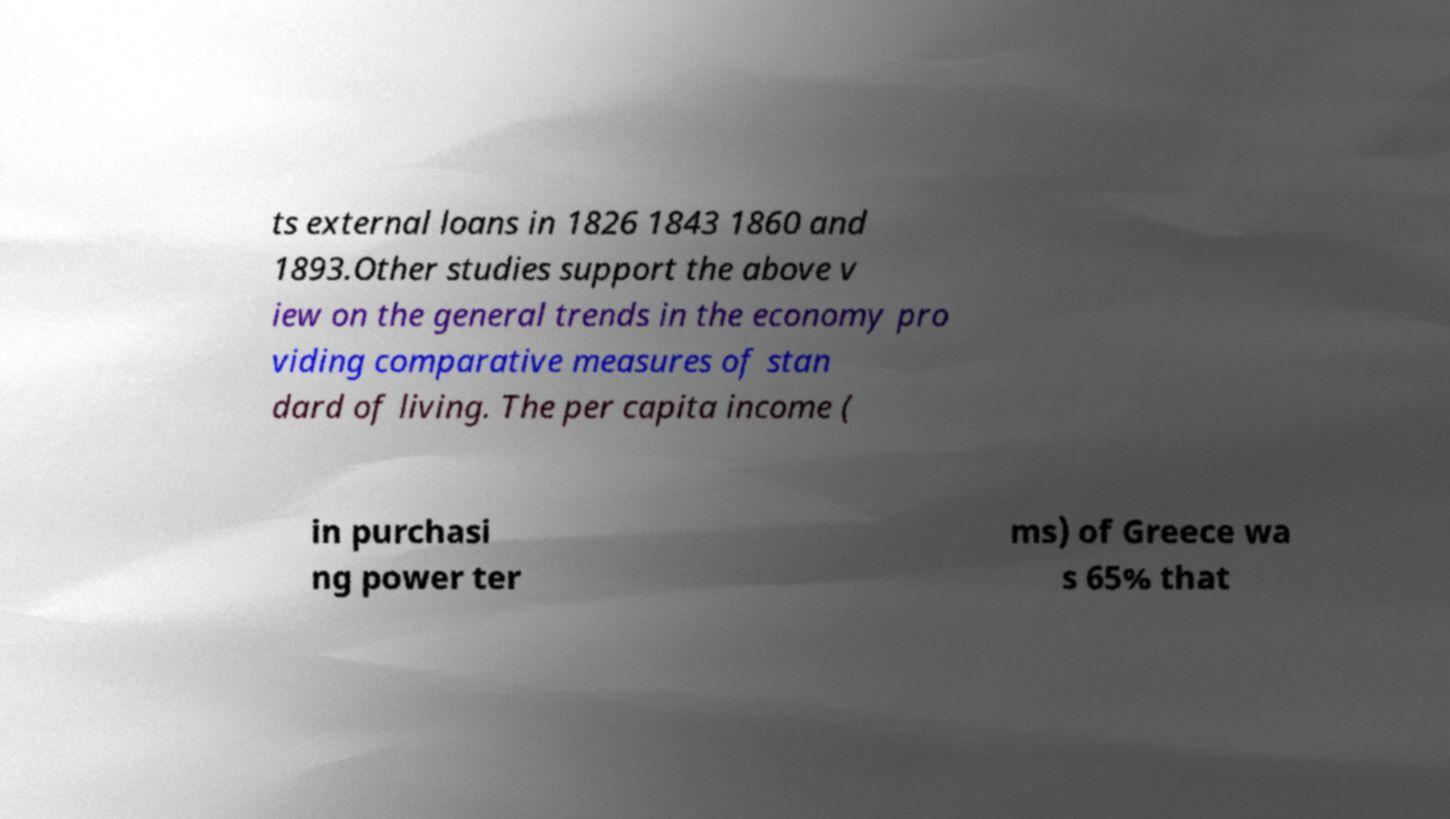I need the written content from this picture converted into text. Can you do that? ts external loans in 1826 1843 1860 and 1893.Other studies support the above v iew on the general trends in the economy pro viding comparative measures of stan dard of living. The per capita income ( in purchasi ng power ter ms) of Greece wa s 65% that 